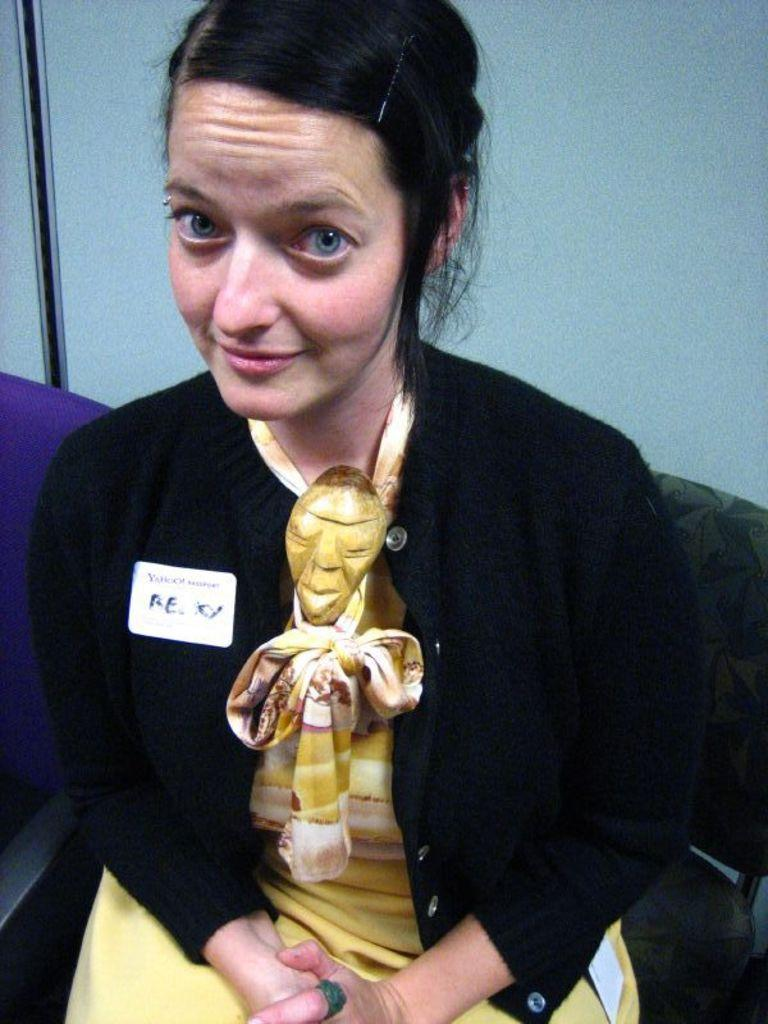What is the woman in the image doing? The woman is sitting on a chair in the image. What is the woman wearing on her upper body? The woman is wearing a black jacket. What is the woman wearing on her lower body? The woman is wearing a yellow dress. Can you describe any additional items the woman is wearing or displaying? There is a badge attached to the woman's clothing. What can be seen in the background of the image? There is a wall visible in the image. What type of trade is being conducted in the image? There is no indication of any trade being conducted in the image; it primarily features a woman sitting on a chair. Can you tell me how many airports are visible in the image? There are no airports present in the image. 